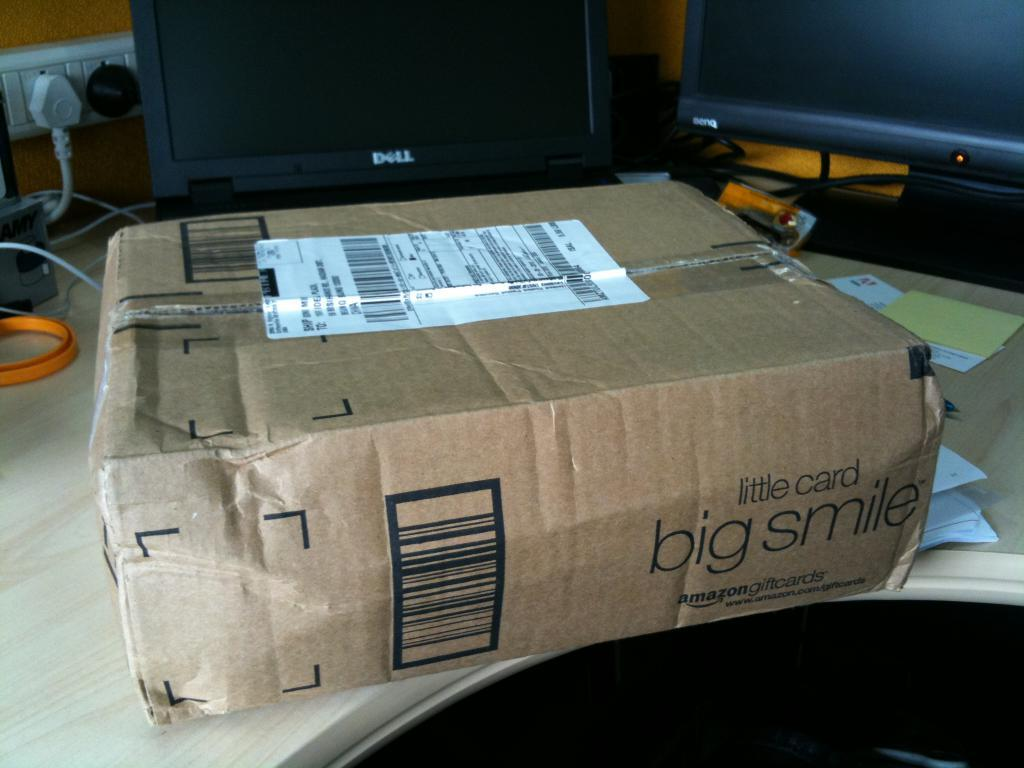What can be seen on the yellow wall in the background of the image? There is a switch board socket on the yellow wall in the background. What electronic devices are present in the image? There are monitors in the image. What type of container is visible in the image? There is a box in the image. What type of paper-based items are present in the image? There are papers in the image. What color is the object mentioned in the image? There is an orange color object in the image. On what surface are the objects placed? The objects mentioned are placed on a wooden table. How does the drain function in the image? There is no drain present in the image. What type of chess pieces can be seen on the table in the image? There are no chess pieces visible in the image. 